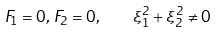Convert formula to latex. <formula><loc_0><loc_0><loc_500><loc_500>F _ { 1 } = 0 , \, F _ { 2 } = 0 , \quad \xi _ { 1 } ^ { 2 } + \xi _ { 2 } ^ { 2 } \ne 0</formula> 